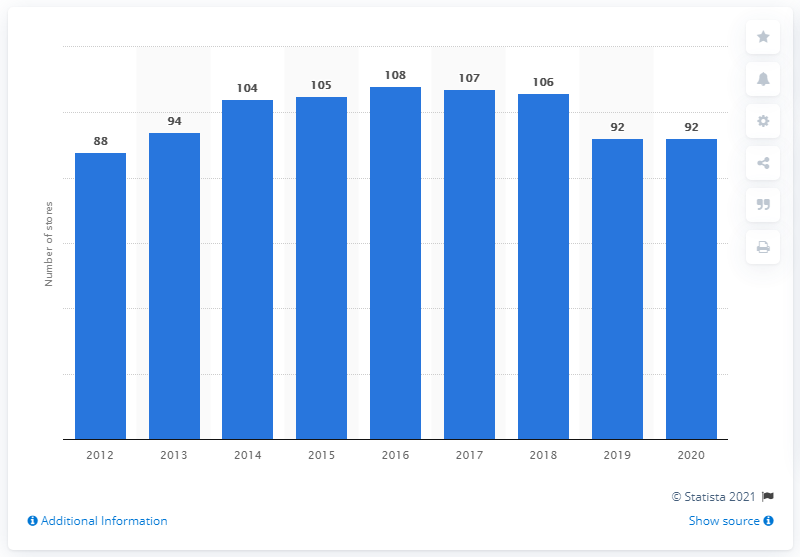Give some essential details in this illustration. In 2018, there were 108 Walmart stores operating in Argentina. In 2020, there were 92 Walmart stores in Argentina. 